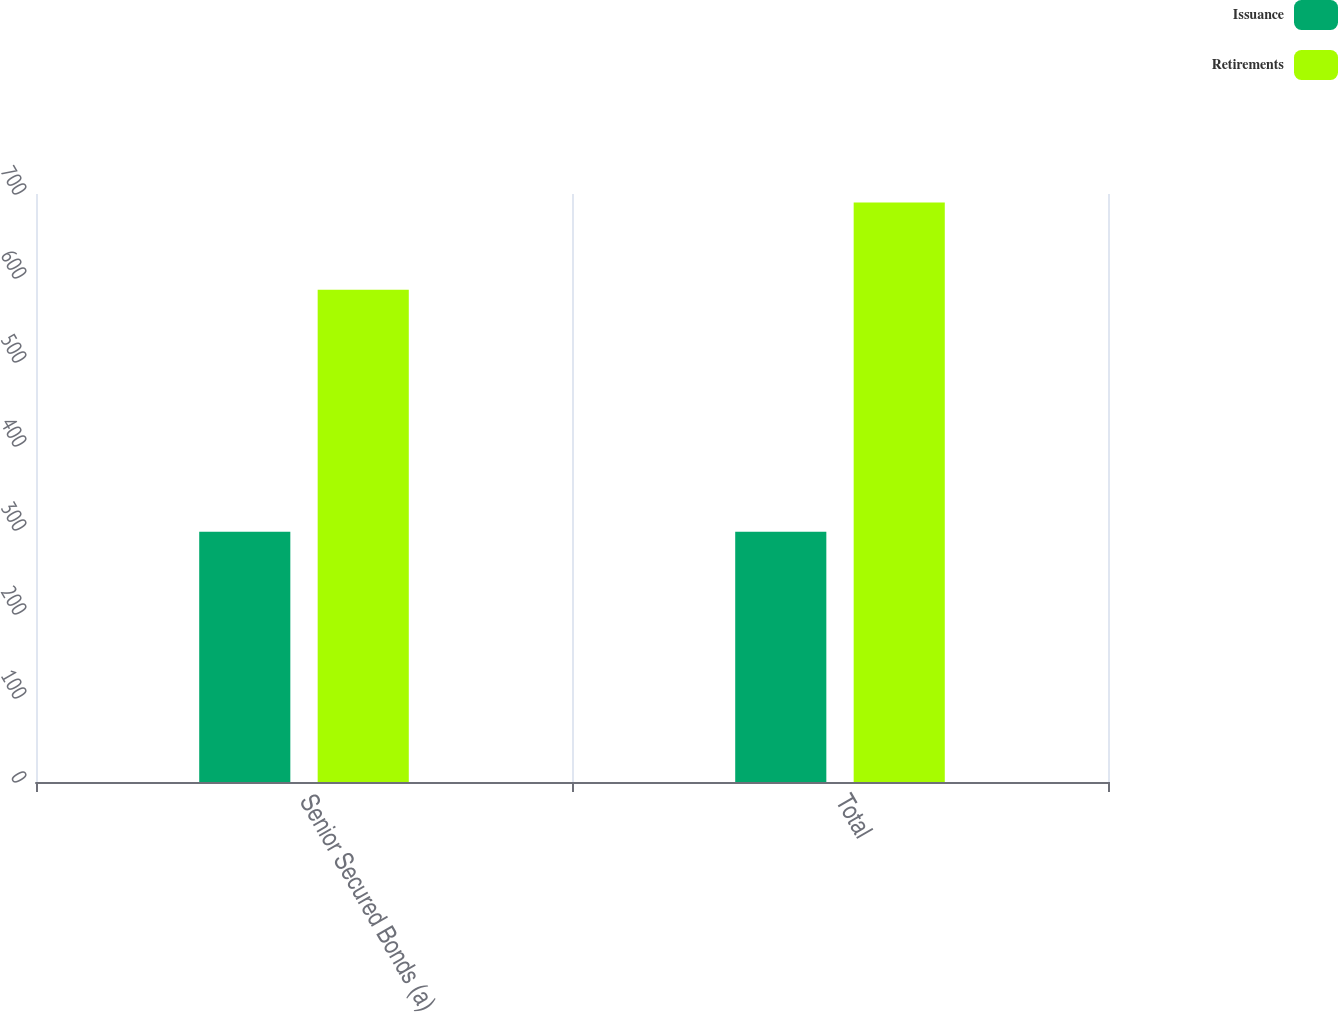<chart> <loc_0><loc_0><loc_500><loc_500><stacked_bar_chart><ecel><fcel>Senior Secured Bonds (a)<fcel>Total<nl><fcel>Issuance<fcel>298<fcel>298<nl><fcel>Retirements<fcel>586<fcel>690<nl></chart> 